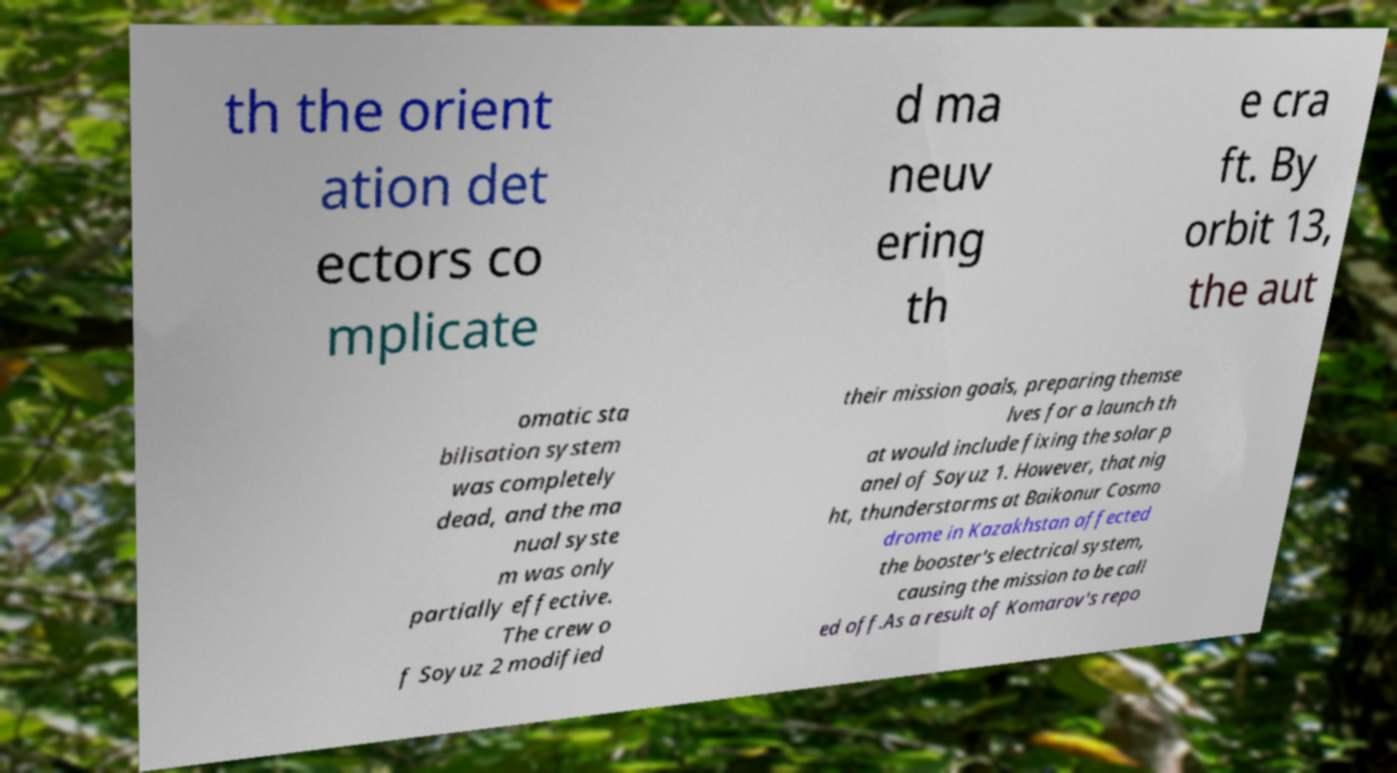Could you extract and type out the text from this image? th the orient ation det ectors co mplicate d ma neuv ering th e cra ft. By orbit 13, the aut omatic sta bilisation system was completely dead, and the ma nual syste m was only partially effective. The crew o f Soyuz 2 modified their mission goals, preparing themse lves for a launch th at would include fixing the solar p anel of Soyuz 1. However, that nig ht, thunderstorms at Baikonur Cosmo drome in Kazakhstan affected the booster's electrical system, causing the mission to be call ed off.As a result of Komarov's repo 